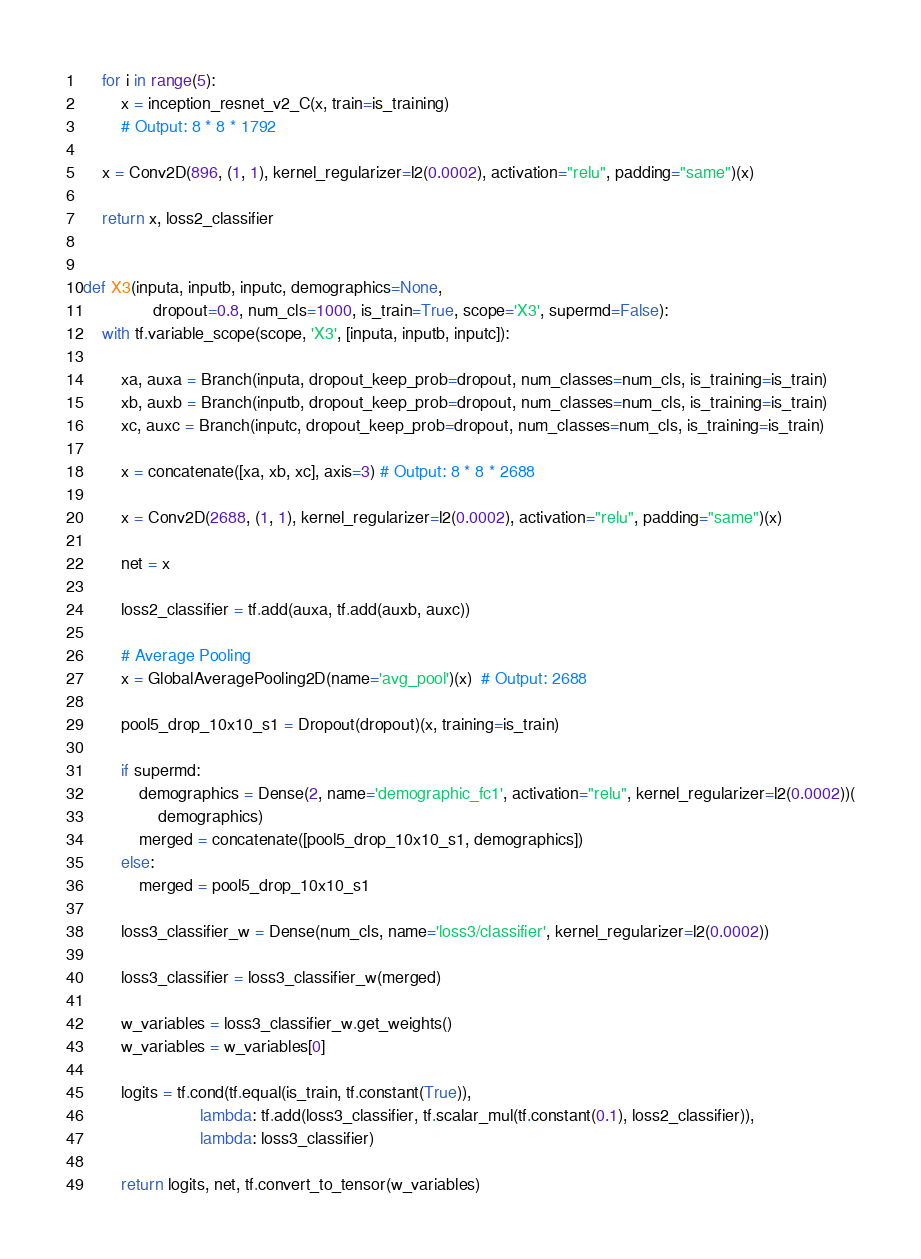<code> <loc_0><loc_0><loc_500><loc_500><_Python_>    for i in range(5):
        x = inception_resnet_v2_C(x, train=is_training)
        # Output: 8 * 8 * 1792

    x = Conv2D(896, (1, 1), kernel_regularizer=l2(0.0002), activation="relu", padding="same")(x)

    return x, loss2_classifier


def X3(inputa, inputb, inputc, demographics=None,
               dropout=0.8, num_cls=1000, is_train=True, scope='X3', supermd=False):
    with tf.variable_scope(scope, 'X3', [inputa, inputb, inputc]):

        xa, auxa = Branch(inputa, dropout_keep_prob=dropout, num_classes=num_cls, is_training=is_train)
        xb, auxb = Branch(inputb, dropout_keep_prob=dropout, num_classes=num_cls, is_training=is_train)
        xc, auxc = Branch(inputc, dropout_keep_prob=dropout, num_classes=num_cls, is_training=is_train)

        x = concatenate([xa, xb, xc], axis=3) # Output: 8 * 8 * 2688

        x = Conv2D(2688, (1, 1), kernel_regularizer=l2(0.0002), activation="relu", padding="same")(x)

        net = x

        loss2_classifier = tf.add(auxa, tf.add(auxb, auxc))

        # Average Pooling
        x = GlobalAveragePooling2D(name='avg_pool')(x)  # Output: 2688

        pool5_drop_10x10_s1 = Dropout(dropout)(x, training=is_train)

        if supermd:
            demographics = Dense(2, name='demographic_fc1', activation="relu", kernel_regularizer=l2(0.0002))(
                demographics)
            merged = concatenate([pool5_drop_10x10_s1, demographics])
        else:
            merged = pool5_drop_10x10_s1

        loss3_classifier_w = Dense(num_cls, name='loss3/classifier', kernel_regularizer=l2(0.0002))

        loss3_classifier = loss3_classifier_w(merged)

        w_variables = loss3_classifier_w.get_weights()
        w_variables = w_variables[0]

        logits = tf.cond(tf.equal(is_train, tf.constant(True)),
                         lambda: tf.add(loss3_classifier, tf.scalar_mul(tf.constant(0.1), loss2_classifier)),
                         lambda: loss3_classifier)

        return logits, net, tf.convert_to_tensor(w_variables)

</code> 